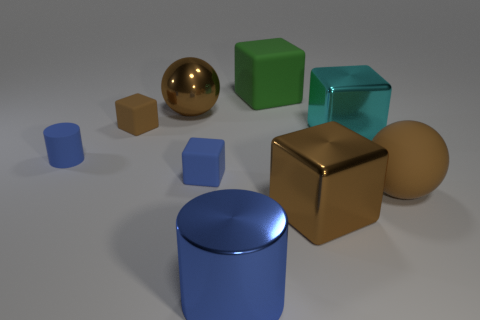Are there more big brown metal balls that are behind the big blue object than tiny matte balls?
Your response must be concise. Yes. There is a cylinder that is right of the brown object that is on the left side of the metallic ball; what color is it?
Offer a terse response. Blue. The cyan thing that is the same size as the green object is what shape?
Provide a short and direct response. Cube. There is a tiny matte thing that is the same color as the small cylinder; what is its shape?
Your response must be concise. Cube. Are there the same number of big brown blocks behind the brown rubber cube and large purple rubber cylinders?
Make the answer very short. Yes. There is a sphere right of the small rubber thing that is right of the large brown metallic object to the left of the blue shiny object; what is its material?
Ensure brevity in your answer.  Rubber. What is the shape of the large brown thing that is the same material as the large green thing?
Keep it short and to the point. Sphere. Is there anything else of the same color as the tiny cylinder?
Offer a terse response. Yes. How many cyan objects are behind the big ball in front of the brown cube on the left side of the large green matte thing?
Provide a short and direct response. 1. How many blue things are either large objects or tiny cylinders?
Your answer should be compact. 2. 